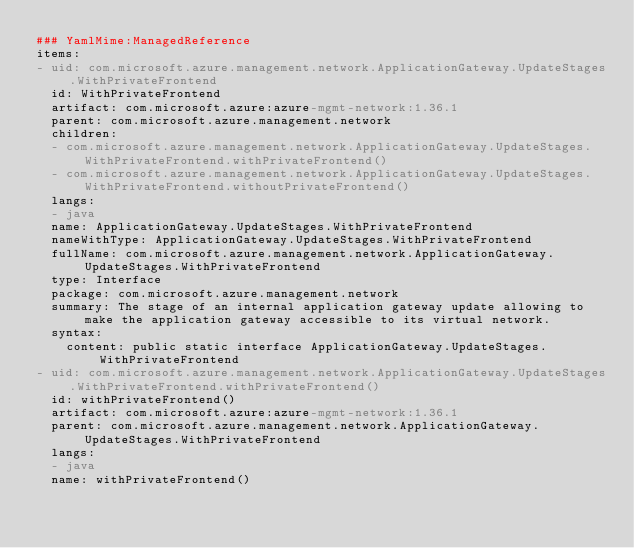Convert code to text. <code><loc_0><loc_0><loc_500><loc_500><_YAML_>### YamlMime:ManagedReference
items:
- uid: com.microsoft.azure.management.network.ApplicationGateway.UpdateStages.WithPrivateFrontend
  id: WithPrivateFrontend
  artifact: com.microsoft.azure:azure-mgmt-network:1.36.1
  parent: com.microsoft.azure.management.network
  children:
  - com.microsoft.azure.management.network.ApplicationGateway.UpdateStages.WithPrivateFrontend.withPrivateFrontend()
  - com.microsoft.azure.management.network.ApplicationGateway.UpdateStages.WithPrivateFrontend.withoutPrivateFrontend()
  langs:
  - java
  name: ApplicationGateway.UpdateStages.WithPrivateFrontend
  nameWithType: ApplicationGateway.UpdateStages.WithPrivateFrontend
  fullName: com.microsoft.azure.management.network.ApplicationGateway.UpdateStages.WithPrivateFrontend
  type: Interface
  package: com.microsoft.azure.management.network
  summary: The stage of an internal application gateway update allowing to make the application gateway accessible to its virtual network.
  syntax:
    content: public static interface ApplicationGateway.UpdateStages.WithPrivateFrontend
- uid: com.microsoft.azure.management.network.ApplicationGateway.UpdateStages.WithPrivateFrontend.withPrivateFrontend()
  id: withPrivateFrontend()
  artifact: com.microsoft.azure:azure-mgmt-network:1.36.1
  parent: com.microsoft.azure.management.network.ApplicationGateway.UpdateStages.WithPrivateFrontend
  langs:
  - java
  name: withPrivateFrontend()</code> 